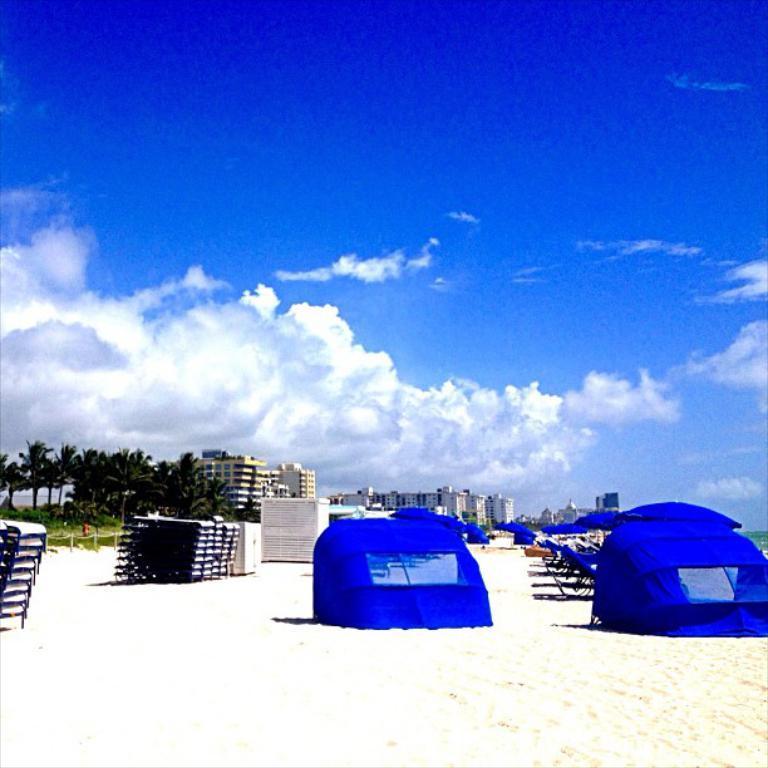How would you summarize this image in a sentence or two? In this picture there are few blue color objects and chairs and there are some other objects beside it and there are trees and buildings in the background and the sky is a bit cloudy. 